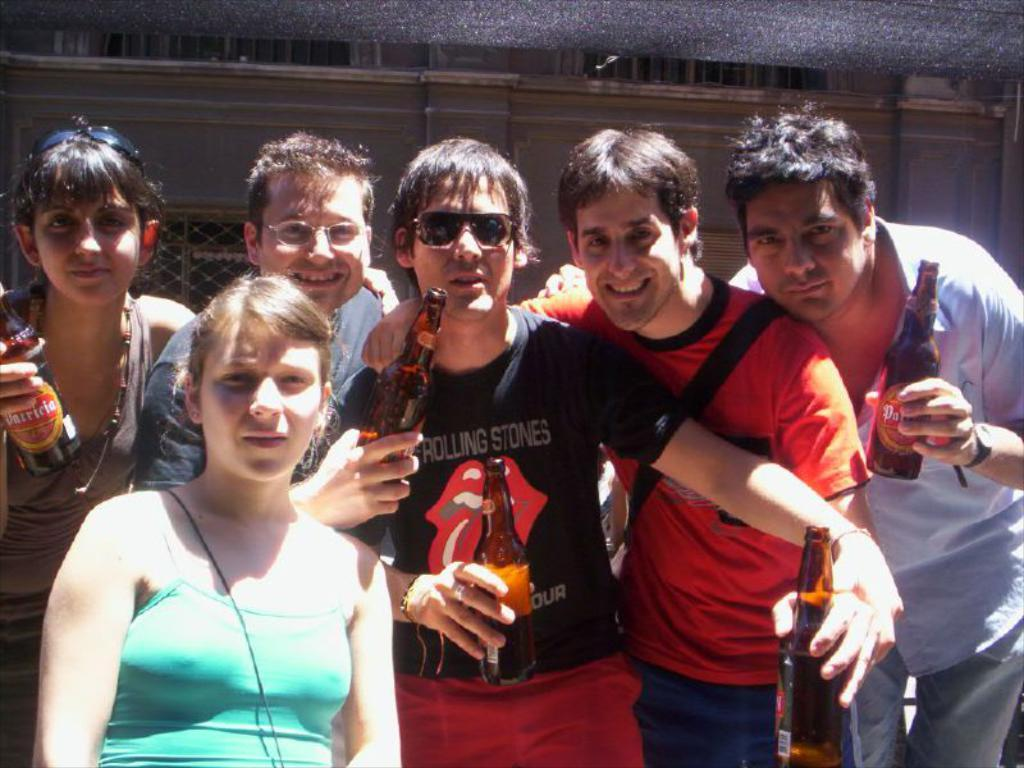How many people are in the image? There is a group of people in the image. What are some of the people in the group holding? Some people in the group are holding bottles. What can be seen in the background of the image? There is a wall in the background of the image. What type of string is being used to control the sail in the image? There is no string or sail present in the image; it features a group of people and a wall in the background. 